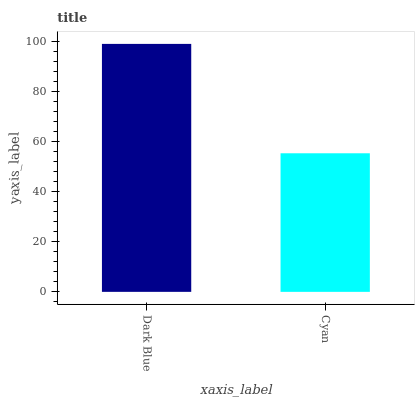Is Cyan the minimum?
Answer yes or no. Yes. Is Dark Blue the maximum?
Answer yes or no. Yes. Is Cyan the maximum?
Answer yes or no. No. Is Dark Blue greater than Cyan?
Answer yes or no. Yes. Is Cyan less than Dark Blue?
Answer yes or no. Yes. Is Cyan greater than Dark Blue?
Answer yes or no. No. Is Dark Blue less than Cyan?
Answer yes or no. No. Is Dark Blue the high median?
Answer yes or no. Yes. Is Cyan the low median?
Answer yes or no. Yes. Is Cyan the high median?
Answer yes or no. No. Is Dark Blue the low median?
Answer yes or no. No. 